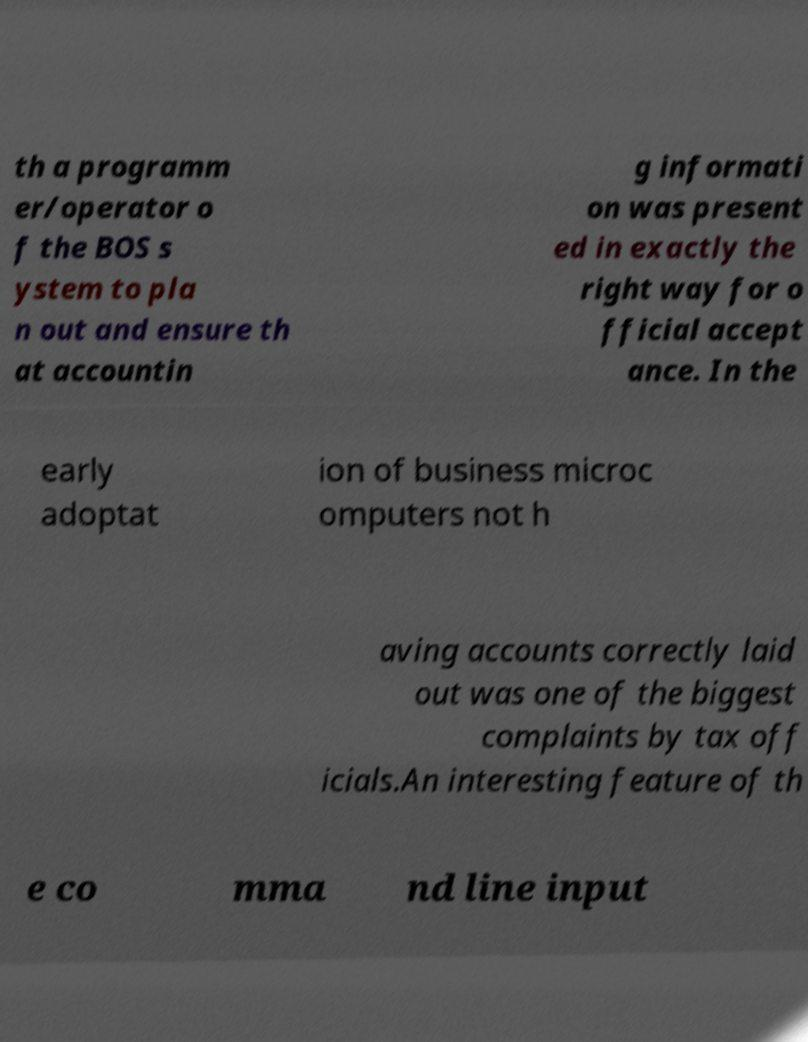Can you read and provide the text displayed in the image?This photo seems to have some interesting text. Can you extract and type it out for me? th a programm er/operator o f the BOS s ystem to pla n out and ensure th at accountin g informati on was present ed in exactly the right way for o fficial accept ance. In the early adoptat ion of business microc omputers not h aving accounts correctly laid out was one of the biggest complaints by tax off icials.An interesting feature of th e co mma nd line input 